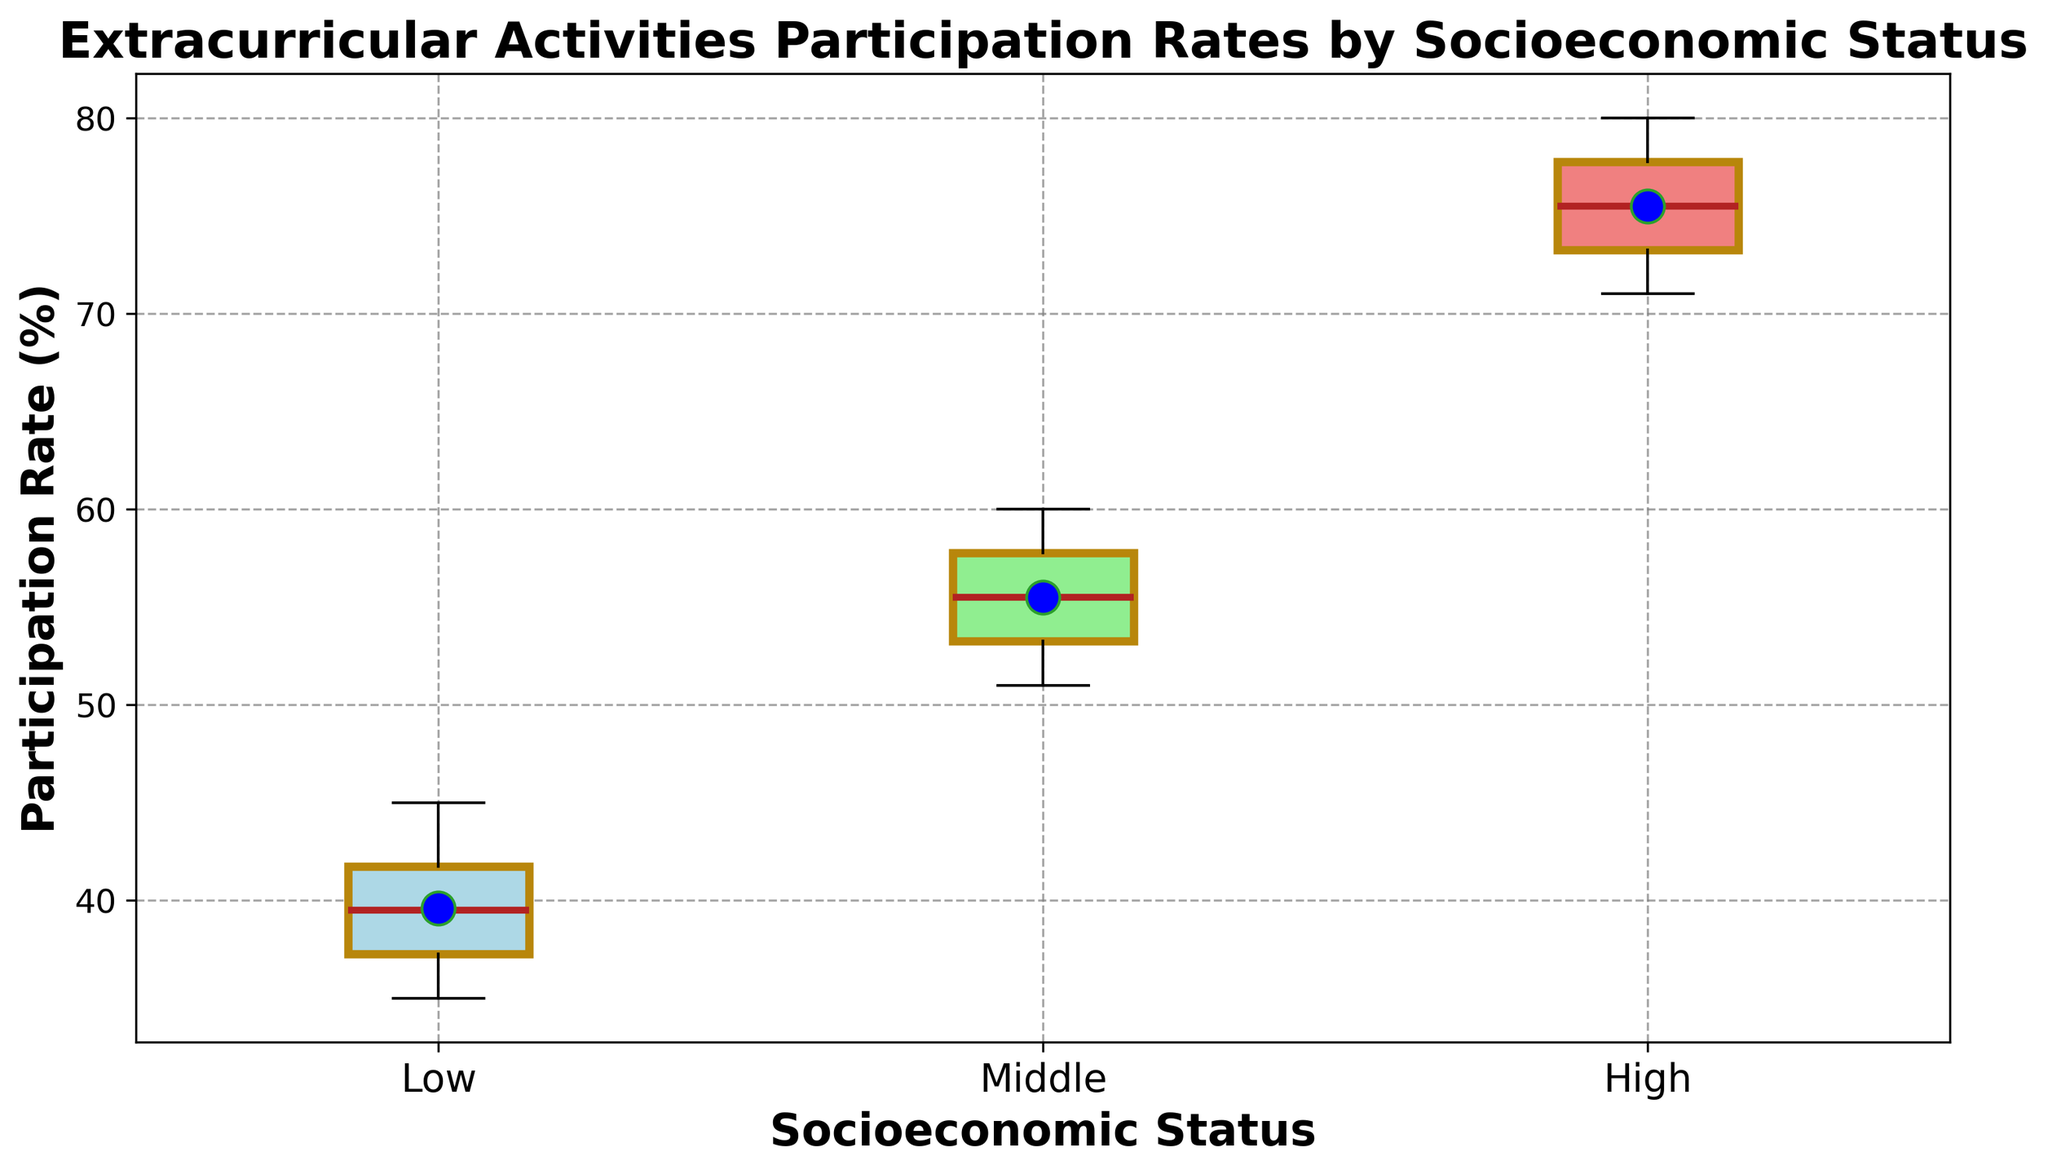What is the participation rate range for the high socioeconomic status group? The participation rate range is the difference between the maximum and minimum values within the high socioeconomic status group. From the box plot, we can identify the highest and lowest points of the 'whiskers' for the high socioeconomic status box. The highest whisker is at 80%, and the lowest whisker is at 71%. Subtracting these values (80% - 71%) gives us the range.
Answer: 9% Which socioeconomic status group has the highest median participation rate? To identify the group with the highest median participation rate, look for the location of the line inside the box that represents the median. The highest median line is inside the box of the high socioeconomic status group.
Answer: High What is the difference between the median participation rates of the middle and low socioeconomic status groups? Examine the box plot to locate the median lines inside the boxes for both the middle and low socioeconomic status groups. The median for the middle group is at 55%, and the median for the low group is at 40%. The difference is calculated by subtracting 40% from 55%.
Answer: 15% Between which two groups does the middle 50% of the extracurricular participation rates overlap? The middle 50% of the data is represented by the box's interquartile range (IQR). To determine if there's an overlap, compare the boxes' positions. The IQR for the middle socioeconomic status group (around 52% to 58%) overlaps with that of the high socioeconomic status group (around 72% to 78%). Therefore, there is no overlap among two groups.
Answer: None In terms of participation rate, which socioeconomic status group shows the most variability? To determine the most variability, we compare the heights of the boxes and the lengths of the whiskers. A larger box and longer whiskers represent more variability. The high socioeconomic status group appears to have the largest spread, indicating the most variability.
Answer: High What is the probable extracurricular participation rate peak for the low socioeconomic status group? The peak, or the most common value in a box plot, often means the highest central tendency. For the low socioeconomic status group, observing the density around the median line, around 40% appears to be the probable peak value.
Answer: 40% Which group has a lower maximum participation rate than the minimum participation rate of the high socioeconomic status group? The minimum participation rate of the high socioeconomic status group is at 71%. By comparing this with the maximum participation rates of other groups, we find that the low socioeconomic group has a maximum of 45%, which is indeed lower.
Answer: Low Considering the overall patterns, how does socioeconomic status relate to extracurricular participation rates? By comparing the box plots, we notice an increasing trend in participation rates from low to high socioeconomic statuses. The central tendency and participation rate both increase as socioeconomic status goes up. This suggests a positive relationship between higher socioeconomic status and higher participation in extracurricular activities.
Answer: Positive relationship 